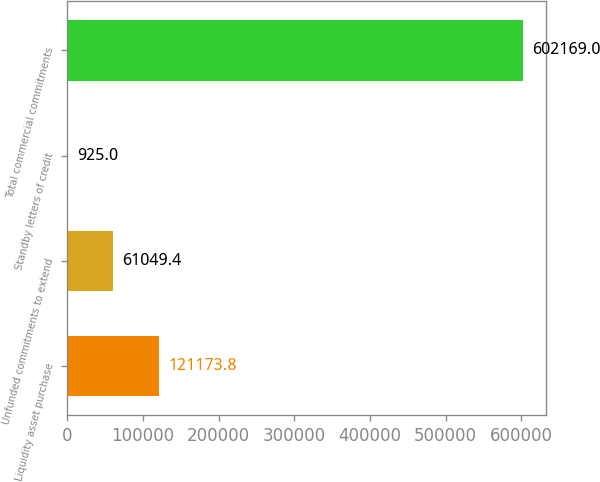<chart> <loc_0><loc_0><loc_500><loc_500><bar_chart><fcel>Liquidity asset purchase<fcel>Unfunded commitments to extend<fcel>Standby letters of credit<fcel>Total commercial commitments<nl><fcel>121174<fcel>61049.4<fcel>925<fcel>602169<nl></chart> 